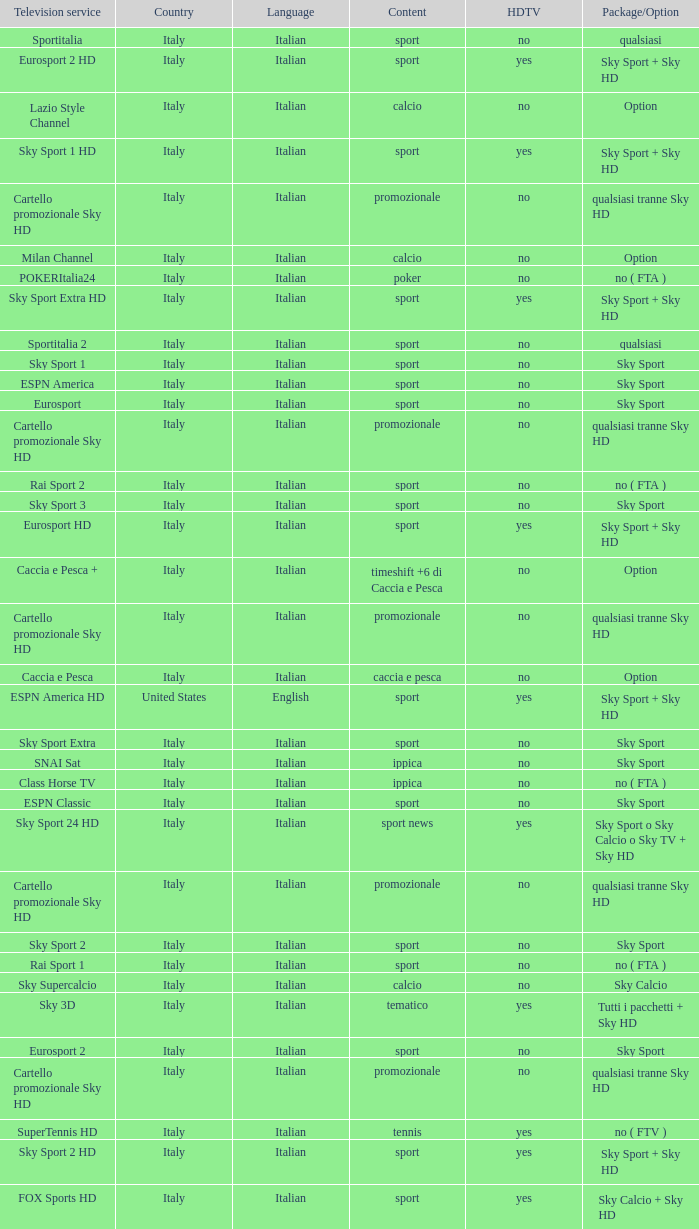What is Television Service, when Content is Calcio, and when Package/Option is Option? Milan Channel, Juventus Channel, Inter Channel, Lazio Style Channel, Roma Channel. 